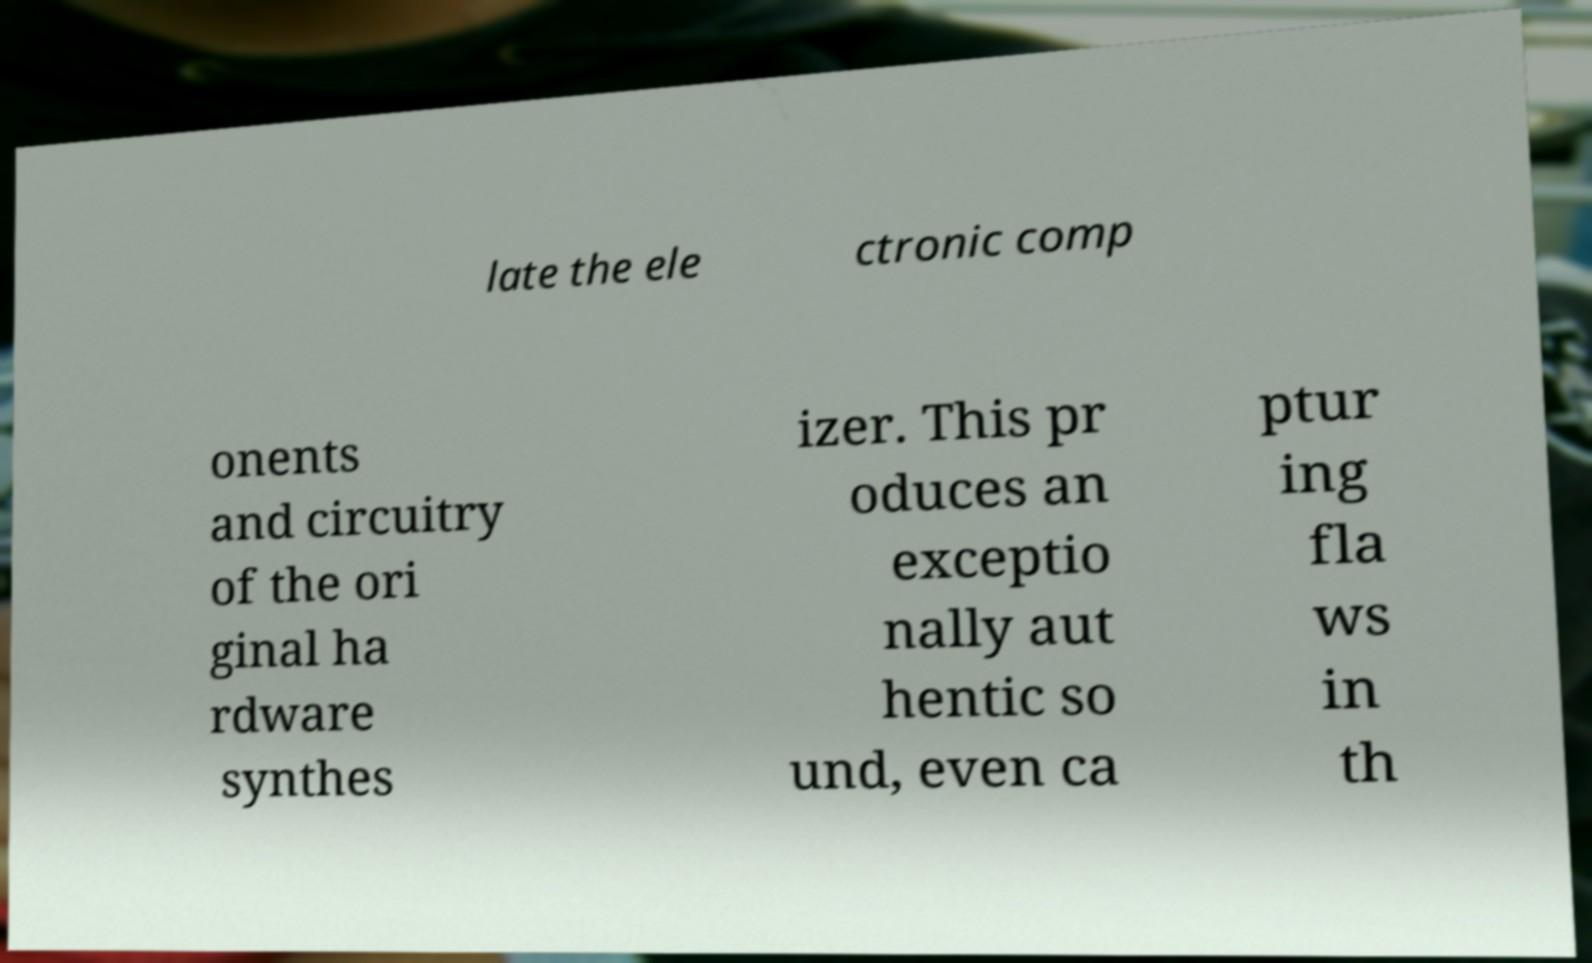Can you read and provide the text displayed in the image?This photo seems to have some interesting text. Can you extract and type it out for me? late the ele ctronic comp onents and circuitry of the ori ginal ha rdware synthes izer. This pr oduces an exceptio nally aut hentic so und, even ca ptur ing fla ws in th 